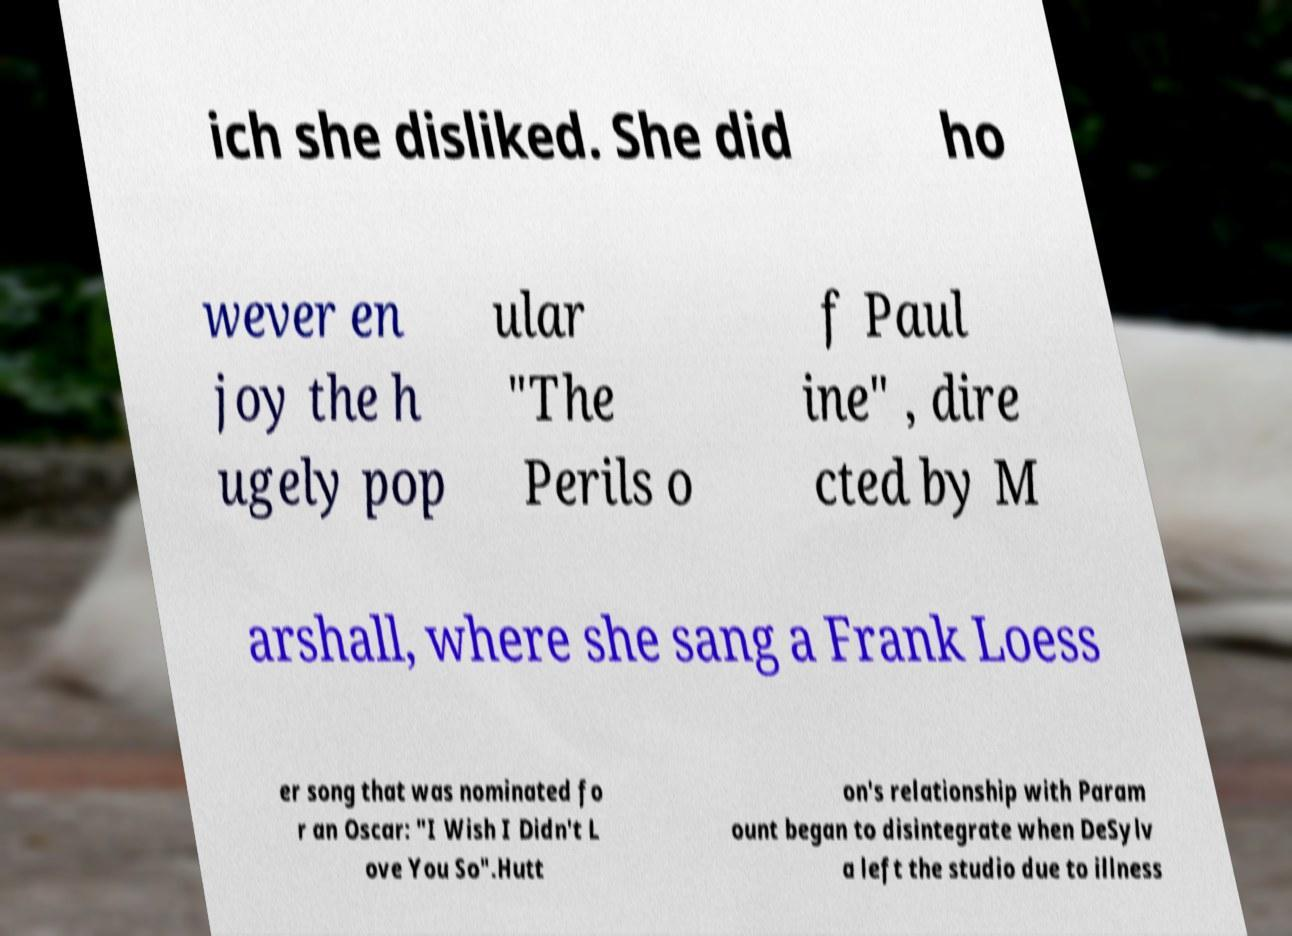Could you assist in decoding the text presented in this image and type it out clearly? ich she disliked. She did ho wever en joy the h ugely pop ular "The Perils o f Paul ine" , dire cted by M arshall, where she sang a Frank Loess er song that was nominated fo r an Oscar: "I Wish I Didn't L ove You So".Hutt on's relationship with Param ount began to disintegrate when DeSylv a left the studio due to illness 